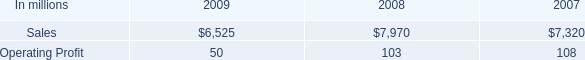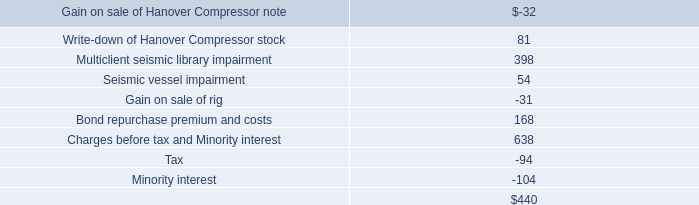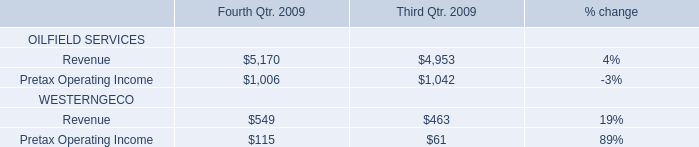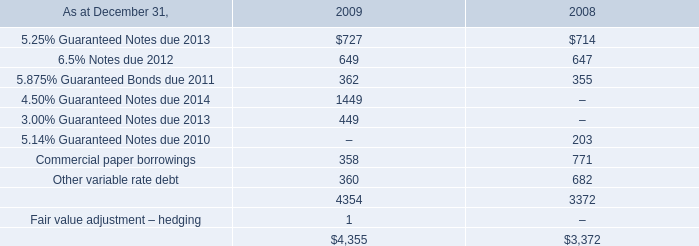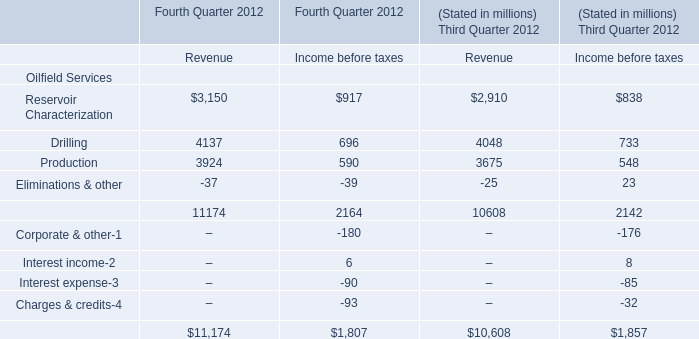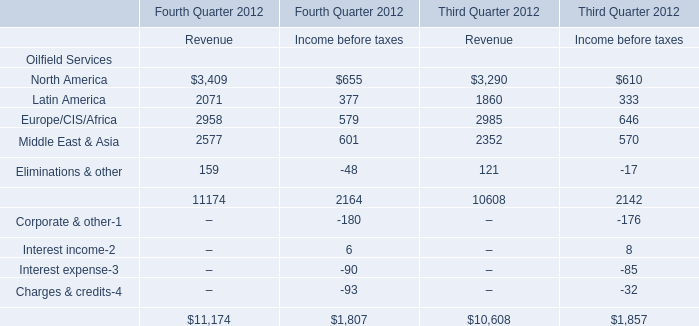What's the total value of all Revenue that are smaller than 4000 for Fourth Quarter 2012? (in million) 
Computations: ((3150 + 3924) - 37)
Answer: 7037.0. 